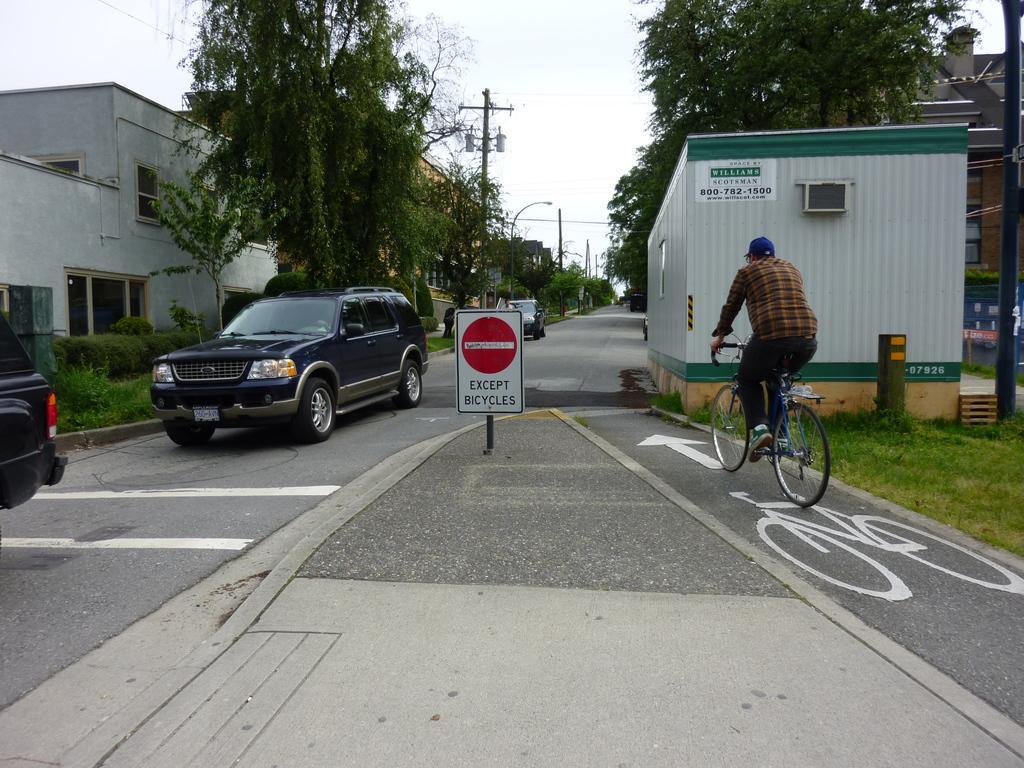Please provide a concise description of this image. This is an outside view. At the bottom I can see a road and there are few cars on the road. On the right side a person is riding the bicycle. In the middle of the road there is a board. In the background, I can see few buildings and trees. Beside the road there are few poles. At the top of the image I can see the sky. On the right side I can see the grass on the ground. 